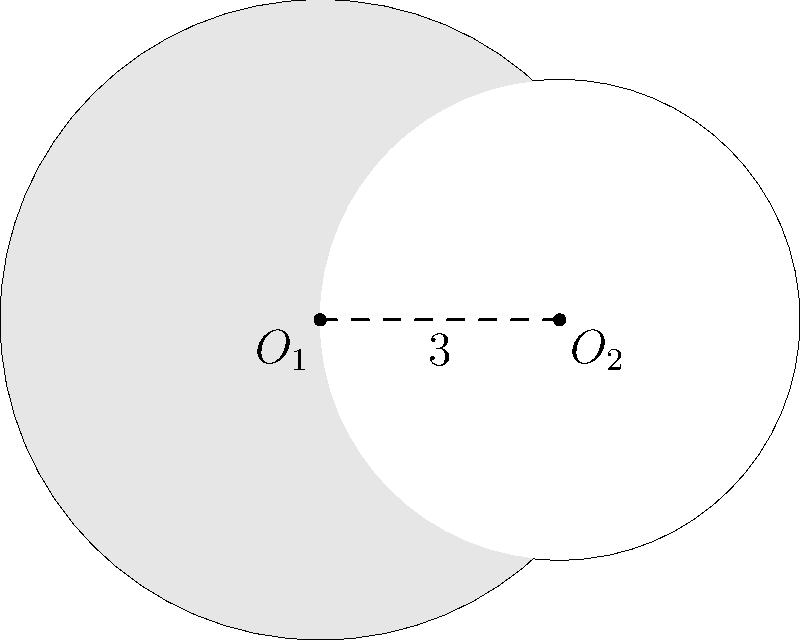As a freelance writer who values privacy and mental well-being, you've been asked to create an article about the mathematical beauty in everyday objects. You decide to focus on the intersection of two circular garden ponds. The centers of these ponds are 3 units apart, with radii of 4 units and 3 units respectively. What is the area of the shaded region formed by the larger pond excluding the overlap with the smaller pond? Let's approach this step-by-step:

1) First, we need to find the area of intersection between the two circles. To do this, we'll use the formula for the area of intersection of two circles:

   $$A = r_1^2 \arccos(\frac{d^2 + r_1^2 - r_2^2}{2dr_1}) + r_2^2 \arccos(\frac{d^2 + r_2^2 - r_1^2}{2dr_2}) - \frac{1}{2}\sqrt{(-d+r_1+r_2)(d+r_1-r_2)(d-r_1+r_2)(d+r_1+r_2)}$$

   Where $r_1 = 4$, $r_2 = 3$, and $d = 3$ (the distance between centers).

2) Plugging in these values:

   $$A = 16 \arccos(\frac{9 + 16 - 9}{24}) + 9 \arccos(\frac{9 + 9 - 16}{18}) - \frac{1}{2}\sqrt{(-3+4+3)(3+4-3)(3-4+3)(3+4+3)}$$

3) Simplifying:

   $$A = 16 \arccos(\frac{2}{3}) + 9 \arccos(\frac{1}{9}) - \frac{1}{2}\sqrt{4 \cdot 4 \cdot 2 \cdot 10}$$

4) Calculating:

   $$A \approx 16 \cdot 0.8411 + 9 \cdot 1.4454 - \frac{1}{2}\sqrt{320} \approx 13.4576 + 13.0086 - 8.9443 \approx 17.5219$$

5) Now, we need to subtract this area of intersection from the area of the larger circle:

   Area of larger circle: $\pi r_1^2 = \pi \cdot 4^2 = 16\pi \approx 50.2655$

6) The shaded area is therefore:

   $$50.2655 - 17.5219 \approx 32.7436$$
Answer: $32.7436$ square units 